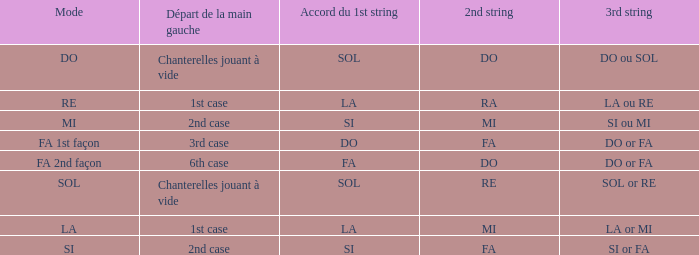Parse the full table. {'header': ['Mode', 'Départ de la main gauche', 'Accord du 1st string', '2nd string', '3rd string'], 'rows': [['DO', 'Chanterelles jouant à vide', 'SOL', 'DO', 'DO ou SOL'], ['RE', '1st case', 'LA', 'RA', 'LA ou RE'], ['MI', '2nd case', 'SI', 'MI', 'SI ou MI'], ['FA 1st façon', '3rd case', 'DO', 'FA', 'DO or FA'], ['FA 2nd façon', '6th case', 'FA', 'DO', 'DO or FA'], ['SOL', 'Chanterelles jouant à vide', 'SOL', 'RE', 'SOL or RE'], ['LA', '1st case', 'LA', 'MI', 'LA or MI'], ['SI', '2nd case', 'SI', 'FA', 'SI or FA']]} What is the mode of the Depart de la main gauche of 1st case and a la or mi 3rd string? LA. 